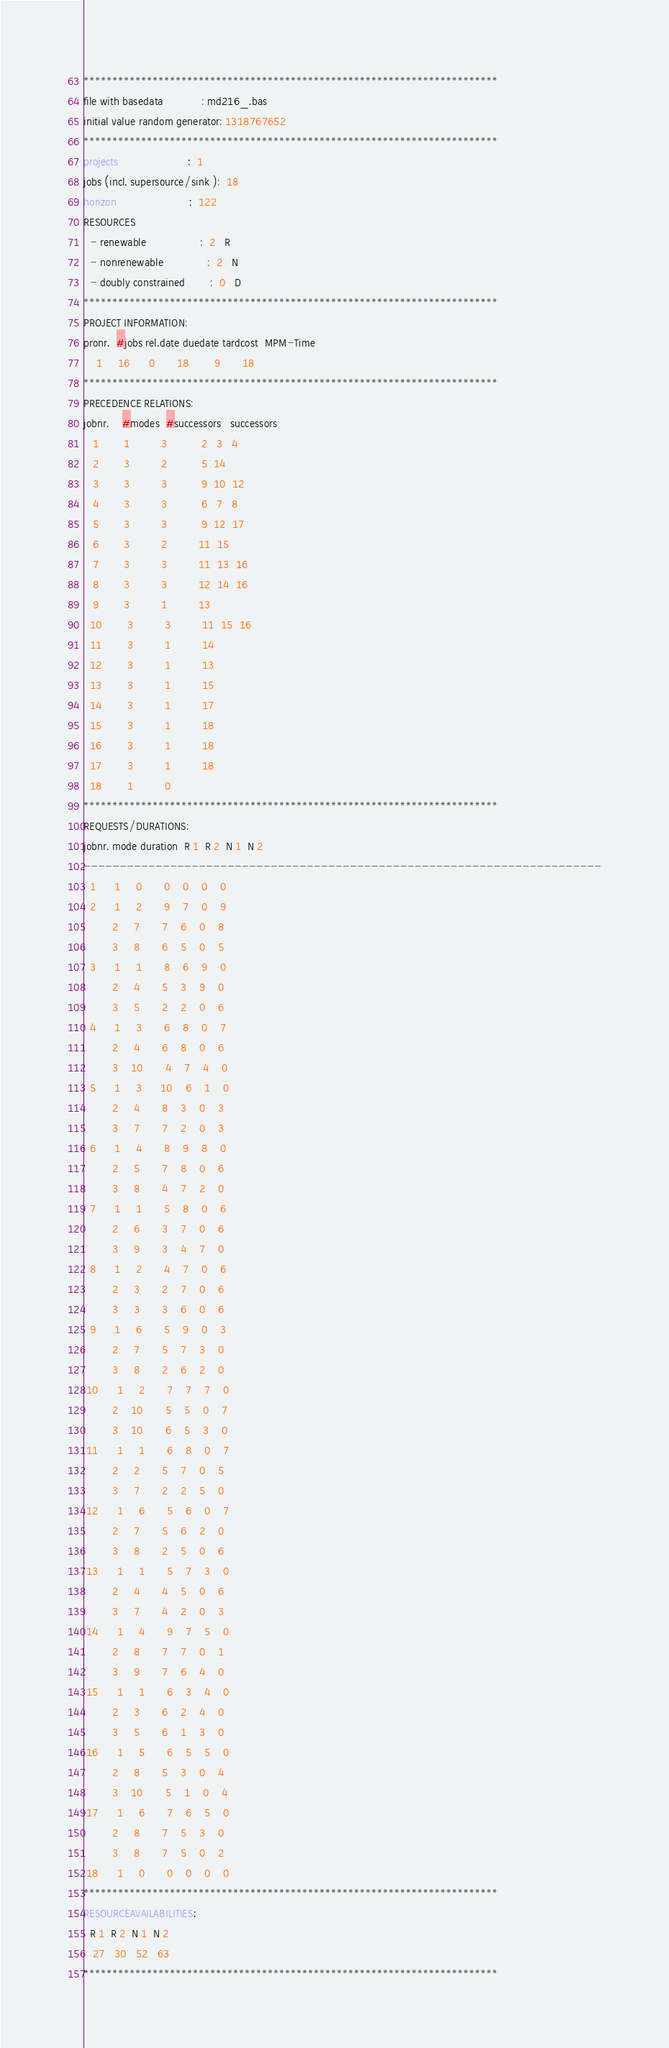<code> <loc_0><loc_0><loc_500><loc_500><_ObjectiveC_>************************************************************************
file with basedata            : md216_.bas
initial value random generator: 1318767652
************************************************************************
projects                      :  1
jobs (incl. supersource/sink ):  18
horizon                       :  122
RESOURCES
  - renewable                 :  2   R
  - nonrenewable              :  2   N
  - doubly constrained        :  0   D
************************************************************************
PROJECT INFORMATION:
pronr.  #jobs rel.date duedate tardcost  MPM-Time
    1     16      0       18        9       18
************************************************************************
PRECEDENCE RELATIONS:
jobnr.    #modes  #successors   successors
   1        1          3           2   3   4
   2        3          2           5  14
   3        3          3           9  10  12
   4        3          3           6   7   8
   5        3          3           9  12  17
   6        3          2          11  15
   7        3          3          11  13  16
   8        3          3          12  14  16
   9        3          1          13
  10        3          3          11  15  16
  11        3          1          14
  12        3          1          13
  13        3          1          15
  14        3          1          17
  15        3          1          18
  16        3          1          18
  17        3          1          18
  18        1          0        
************************************************************************
REQUESTS/DURATIONS:
jobnr. mode duration  R 1  R 2  N 1  N 2
------------------------------------------------------------------------
  1      1     0       0    0    0    0
  2      1     2       9    7    0    9
         2     7       7    6    0    8
         3     8       6    5    0    5
  3      1     1       8    6    9    0
         2     4       5    3    9    0
         3     5       2    2    0    6
  4      1     3       6    8    0    7
         2     4       6    8    0    6
         3    10       4    7    4    0
  5      1     3      10    6    1    0
         2     4       8    3    0    3
         3     7       7    2    0    3
  6      1     4       8    9    8    0
         2     5       7    8    0    6
         3     8       4    7    2    0
  7      1     1       5    8    0    6
         2     6       3    7    0    6
         3     9       3    4    7    0
  8      1     2       4    7    0    6
         2     3       2    7    0    6
         3     3       3    6    0    6
  9      1     6       5    9    0    3
         2     7       5    7    3    0
         3     8       2    6    2    0
 10      1     2       7    7    7    0
         2    10       5    5    0    7
         3    10       6    5    3    0
 11      1     1       6    8    0    7
         2     2       5    7    0    5
         3     7       2    2    5    0
 12      1     6       5    6    0    7
         2     7       5    6    2    0
         3     8       2    5    0    6
 13      1     1       5    7    3    0
         2     4       4    5    0    6
         3     7       4    2    0    3
 14      1     4       9    7    5    0
         2     8       7    7    0    1
         3     9       7    6    4    0
 15      1     1       6    3    4    0
         2     3       6    2    4    0
         3     5       6    1    3    0
 16      1     5       6    5    5    0
         2     8       5    3    0    4
         3    10       5    1    0    4
 17      1     6       7    6    5    0
         2     8       7    5    3    0
         3     8       7    5    0    2
 18      1     0       0    0    0    0
************************************************************************
RESOURCEAVAILABILITIES:
  R 1  R 2  N 1  N 2
   27   30   52   63
************************************************************************
</code> 